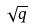<formula> <loc_0><loc_0><loc_500><loc_500>\sqrt { q }</formula> 